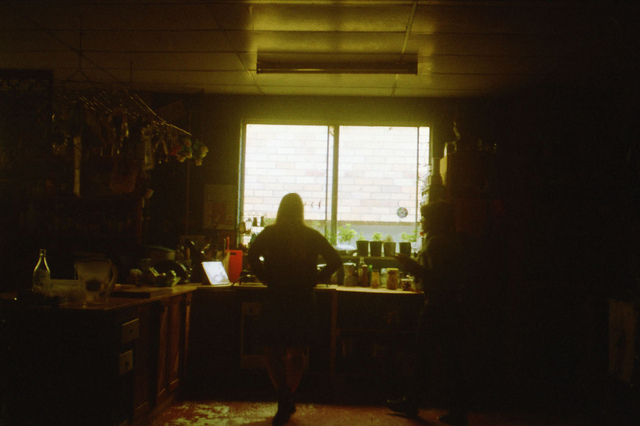Is the hallway wide or narrow? Based on the image, the hallway appears to be relatively narrow. The perspective shown does not provide a wide field of view, and the proximity of visible walls suggests a more confined space. 